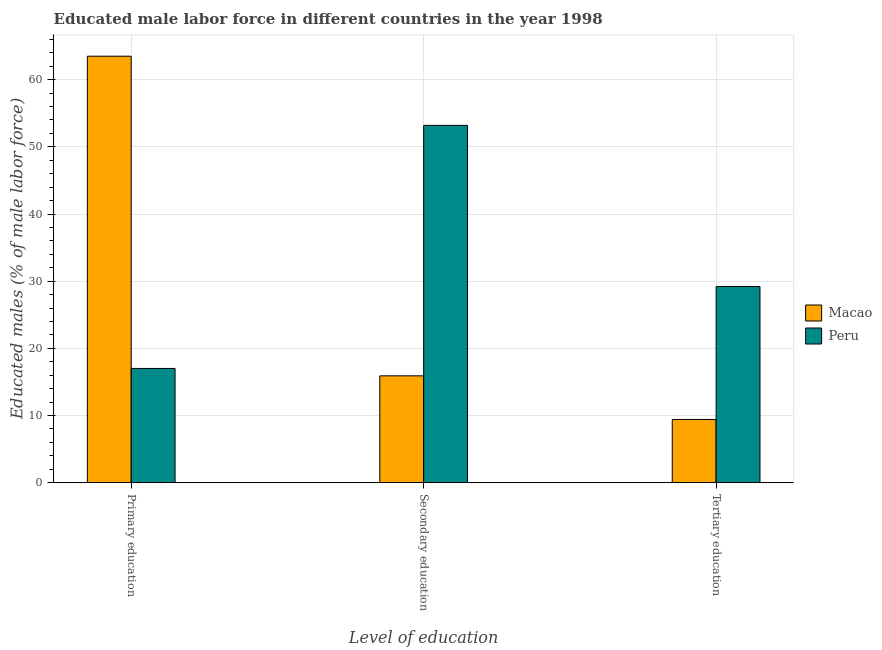How many groups of bars are there?
Offer a very short reply. 3. How many bars are there on the 3rd tick from the left?
Your response must be concise. 2. What is the label of the 3rd group of bars from the left?
Provide a succinct answer. Tertiary education. What is the percentage of male labor force who received tertiary education in Peru?
Provide a short and direct response. 29.2. Across all countries, what is the maximum percentage of male labor force who received tertiary education?
Ensure brevity in your answer.  29.2. Across all countries, what is the minimum percentage of male labor force who received tertiary education?
Ensure brevity in your answer.  9.4. In which country was the percentage of male labor force who received primary education maximum?
Your response must be concise. Macao. In which country was the percentage of male labor force who received secondary education minimum?
Give a very brief answer. Macao. What is the total percentage of male labor force who received primary education in the graph?
Make the answer very short. 80.5. What is the difference between the percentage of male labor force who received secondary education in Macao and that in Peru?
Keep it short and to the point. -37.3. What is the difference between the percentage of male labor force who received tertiary education in Peru and the percentage of male labor force who received primary education in Macao?
Make the answer very short. -34.3. What is the average percentage of male labor force who received tertiary education per country?
Keep it short and to the point. 19.3. What is the difference between the percentage of male labor force who received tertiary education and percentage of male labor force who received primary education in Macao?
Ensure brevity in your answer.  -54.1. What is the ratio of the percentage of male labor force who received tertiary education in Peru to that in Macao?
Your response must be concise. 3.11. Is the percentage of male labor force who received primary education in Macao less than that in Peru?
Provide a succinct answer. No. What is the difference between the highest and the second highest percentage of male labor force who received primary education?
Make the answer very short. 46.5. What is the difference between the highest and the lowest percentage of male labor force who received secondary education?
Make the answer very short. 37.3. What does the 2nd bar from the left in Primary education represents?
Make the answer very short. Peru. What does the 2nd bar from the right in Primary education represents?
Give a very brief answer. Macao. How many countries are there in the graph?
Offer a very short reply. 2. Does the graph contain grids?
Ensure brevity in your answer.  Yes. Where does the legend appear in the graph?
Ensure brevity in your answer.  Center right. How many legend labels are there?
Offer a very short reply. 2. What is the title of the graph?
Offer a terse response. Educated male labor force in different countries in the year 1998. Does "Pacific island small states" appear as one of the legend labels in the graph?
Your answer should be compact. No. What is the label or title of the X-axis?
Offer a terse response. Level of education. What is the label or title of the Y-axis?
Your answer should be compact. Educated males (% of male labor force). What is the Educated males (% of male labor force) of Macao in Primary education?
Provide a succinct answer. 63.5. What is the Educated males (% of male labor force) of Macao in Secondary education?
Provide a short and direct response. 15.9. What is the Educated males (% of male labor force) of Peru in Secondary education?
Your answer should be very brief. 53.2. What is the Educated males (% of male labor force) of Macao in Tertiary education?
Your answer should be very brief. 9.4. What is the Educated males (% of male labor force) of Peru in Tertiary education?
Make the answer very short. 29.2. Across all Level of education, what is the maximum Educated males (% of male labor force) in Macao?
Offer a terse response. 63.5. Across all Level of education, what is the maximum Educated males (% of male labor force) in Peru?
Your answer should be compact. 53.2. Across all Level of education, what is the minimum Educated males (% of male labor force) of Macao?
Provide a short and direct response. 9.4. What is the total Educated males (% of male labor force) in Macao in the graph?
Your answer should be compact. 88.8. What is the total Educated males (% of male labor force) in Peru in the graph?
Give a very brief answer. 99.4. What is the difference between the Educated males (% of male labor force) in Macao in Primary education and that in Secondary education?
Give a very brief answer. 47.6. What is the difference between the Educated males (% of male labor force) in Peru in Primary education and that in Secondary education?
Provide a succinct answer. -36.2. What is the difference between the Educated males (% of male labor force) in Macao in Primary education and that in Tertiary education?
Ensure brevity in your answer.  54.1. What is the difference between the Educated males (% of male labor force) of Peru in Secondary education and that in Tertiary education?
Offer a very short reply. 24. What is the difference between the Educated males (% of male labor force) of Macao in Primary education and the Educated males (% of male labor force) of Peru in Tertiary education?
Make the answer very short. 34.3. What is the difference between the Educated males (% of male labor force) of Macao in Secondary education and the Educated males (% of male labor force) of Peru in Tertiary education?
Your answer should be very brief. -13.3. What is the average Educated males (% of male labor force) of Macao per Level of education?
Offer a very short reply. 29.6. What is the average Educated males (% of male labor force) in Peru per Level of education?
Make the answer very short. 33.13. What is the difference between the Educated males (% of male labor force) of Macao and Educated males (% of male labor force) of Peru in Primary education?
Provide a succinct answer. 46.5. What is the difference between the Educated males (% of male labor force) of Macao and Educated males (% of male labor force) of Peru in Secondary education?
Your answer should be compact. -37.3. What is the difference between the Educated males (% of male labor force) in Macao and Educated males (% of male labor force) in Peru in Tertiary education?
Offer a terse response. -19.8. What is the ratio of the Educated males (% of male labor force) in Macao in Primary education to that in Secondary education?
Your answer should be compact. 3.99. What is the ratio of the Educated males (% of male labor force) of Peru in Primary education to that in Secondary education?
Give a very brief answer. 0.32. What is the ratio of the Educated males (% of male labor force) in Macao in Primary education to that in Tertiary education?
Keep it short and to the point. 6.76. What is the ratio of the Educated males (% of male labor force) of Peru in Primary education to that in Tertiary education?
Offer a very short reply. 0.58. What is the ratio of the Educated males (% of male labor force) in Macao in Secondary education to that in Tertiary education?
Your response must be concise. 1.69. What is the ratio of the Educated males (% of male labor force) in Peru in Secondary education to that in Tertiary education?
Provide a short and direct response. 1.82. What is the difference between the highest and the second highest Educated males (% of male labor force) of Macao?
Keep it short and to the point. 47.6. What is the difference between the highest and the second highest Educated males (% of male labor force) in Peru?
Provide a succinct answer. 24. What is the difference between the highest and the lowest Educated males (% of male labor force) in Macao?
Provide a short and direct response. 54.1. What is the difference between the highest and the lowest Educated males (% of male labor force) of Peru?
Make the answer very short. 36.2. 